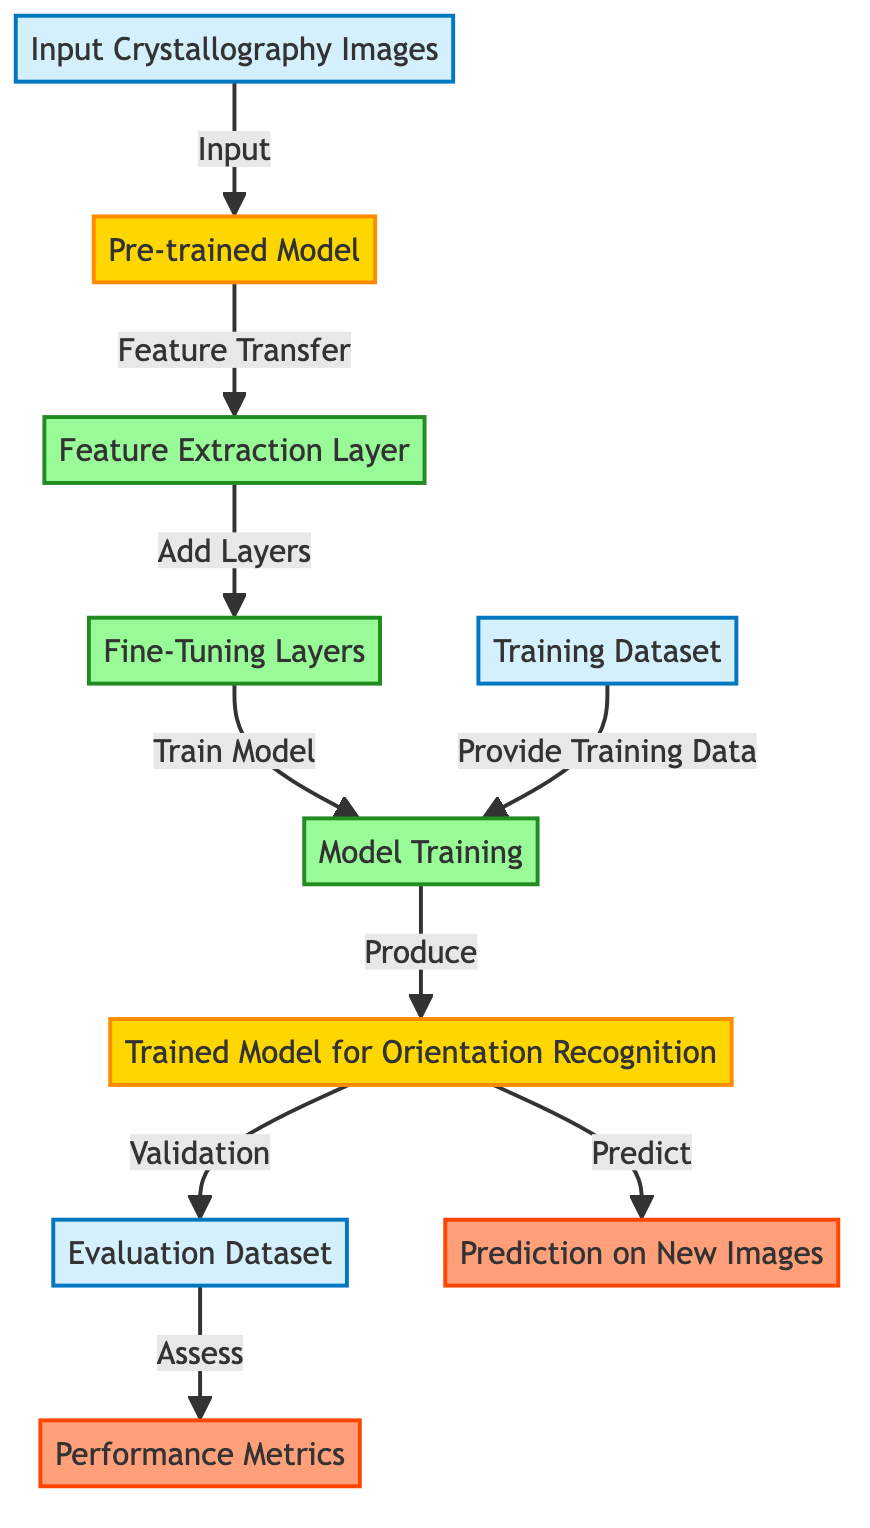What is the first step in the process? The diagram indicates that the first step involves "Input Crystallography Images" as represented in node 1. This is the initial action before any processing occurs.
Answer: Input Crystallography Images How many models are represented in the diagram? The diagram shows two models: the "Pre-trained Model" and the "Trained Model for Orientation Recognition," identifying nodes 2 and 7 as models.
Answer: Two models Which layer is responsible for feature extraction? The "Feature Extraction Layer" is specifically identified as node 3 in the diagram, where the pre-trained model transfers its learned features for further processing.
Answer: Feature Extraction Layer What type of data is used for training the model? The training model receives a "Training Dataset," noted at node 5, which provides the necessary data for the training process.
Answer: Training Dataset What metric is used to evaluate the model's performance? The diagram highlights "Performance Metrics" as the outcome of the evaluation process, which is depicted at node 9. This indicates the criteria used to assess the model's effectiveness.
Answer: Performance Metrics What are the two outputs after the model has been trained? The diagram shows two outputs after training: "Prediction on New Images" from node 10 and "Performance Metrics" from node 9, both coming from node 7.
Answer: Prediction on New Images and Performance Metrics Which node represents the fine-tuning process? Node 4, labeled "Fine-Tuning Layers," specifically denotes the part of the process where adjustments are made to the model after feature extraction.
Answer: Fine-Tuning Layers How does the model obtain its features for the training process? The model obtains its features through "Feature Transfer" from the "Pre-trained Model," indicated by the directed connection from node 2 to node 3.
Answer: Feature Transfer How does the diagram indicate the validation process? The diagram illustrates validation through the relationship from the "Trained Model for Orientation Recognition" (node 7) to "Evaluation Dataset" (node 8), showing how the model is validated against a separate dataset.
Answer: Validation process indicated by the relationship from node 7 to node 8 